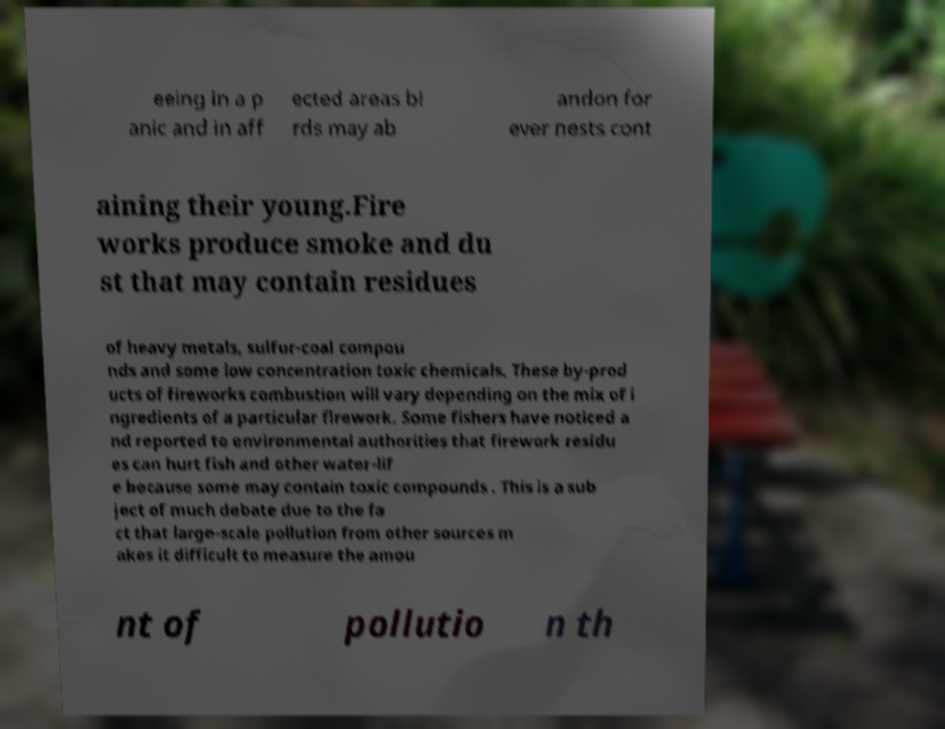Could you extract and type out the text from this image? eeing in a p anic and in aff ected areas bi rds may ab andon for ever nests cont aining their young.Fire works produce smoke and du st that may contain residues of heavy metals, sulfur-coal compou nds and some low concentration toxic chemicals. These by-prod ucts of fireworks combustion will vary depending on the mix of i ngredients of a particular firework. Some fishers have noticed a nd reported to environmental authorities that firework residu es can hurt fish and other water-lif e because some may contain toxic compounds . This is a sub ject of much debate due to the fa ct that large-scale pollution from other sources m akes it difficult to measure the amou nt of pollutio n th 